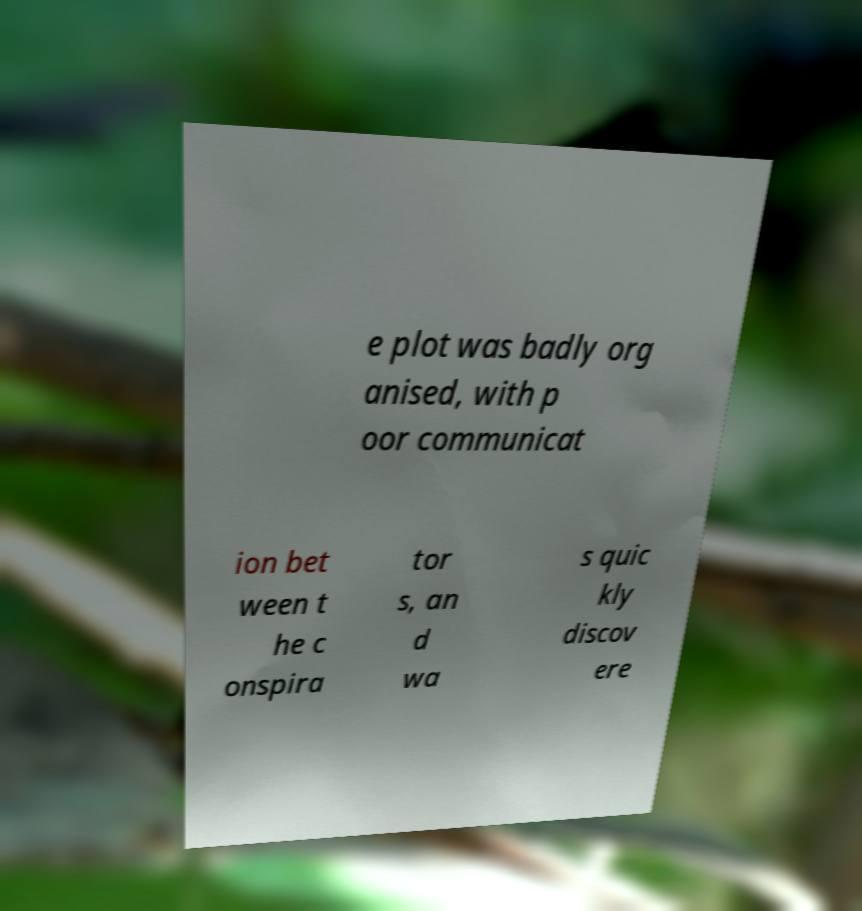What messages or text are displayed in this image? I need them in a readable, typed format. e plot was badly org anised, with p oor communicat ion bet ween t he c onspira tor s, an d wa s quic kly discov ere 